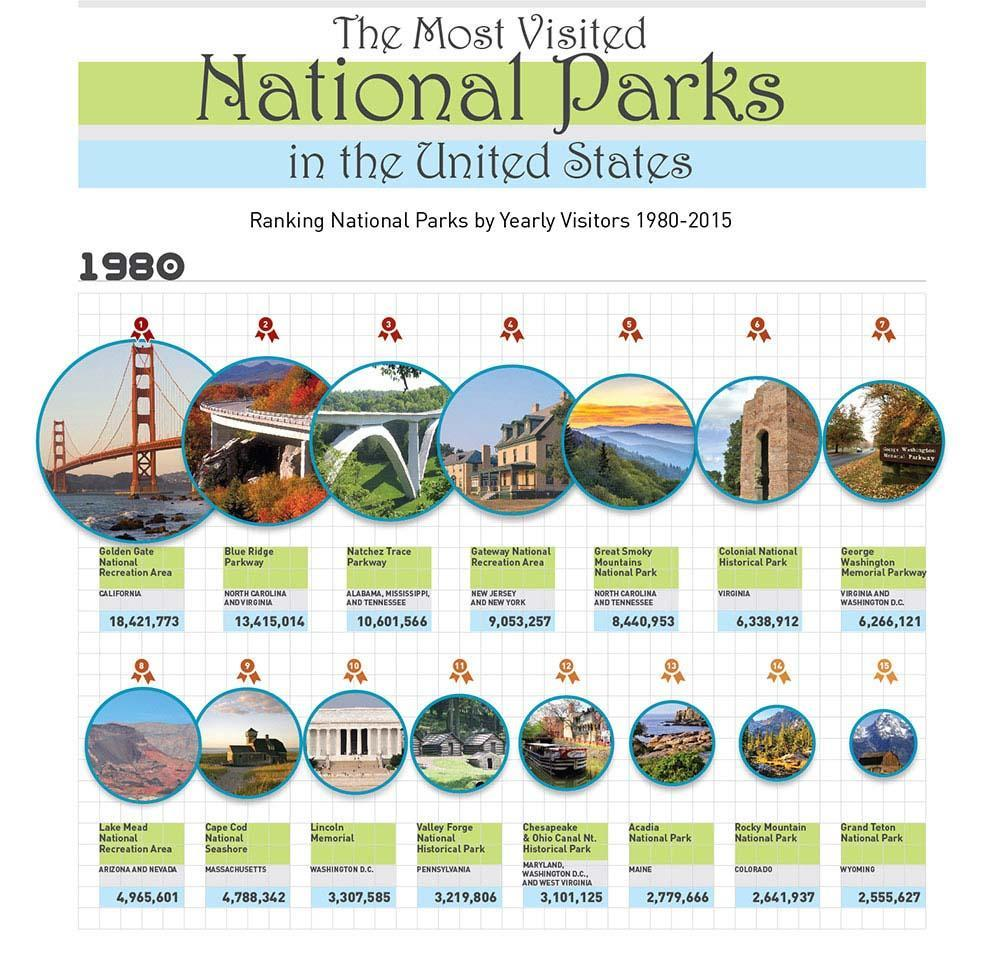In which state is Golden Gate National Recreation Area?
Answer the question with a short phrase. California Which National park was ranked 15 in 1980? Grand Teton National Park What was the number of visitors to Cape Cod National Seashore in 1980? 4,788,342 Which National Park is located in Maine? Acadia National Park In which state is Colonial National Historical Park situated? Virginia Which National Park had 3,307,585 visitors in the year 1980? Lincoln Memorial Where is Valley Forge National Historical Park located? Pennsylvania Which National Park was ranked 2 in 1980? Blue Ridge Parkway What was the ranking of Great Smoky Mountains National Park in 1980? 5 Which National Park in located in the states of Alabama, Mississippi and Tennessee? Natchez Trace Parkway 